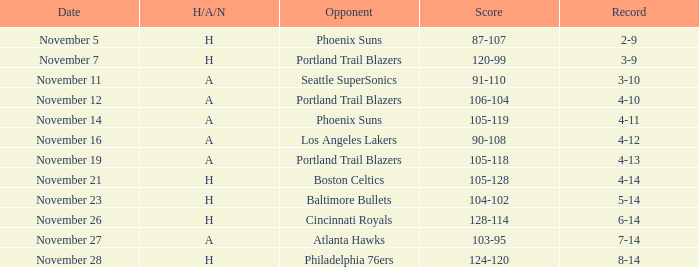What is the Opponent of the game with a H/A/N of H and Score of 120-99? Portland Trail Blazers. 